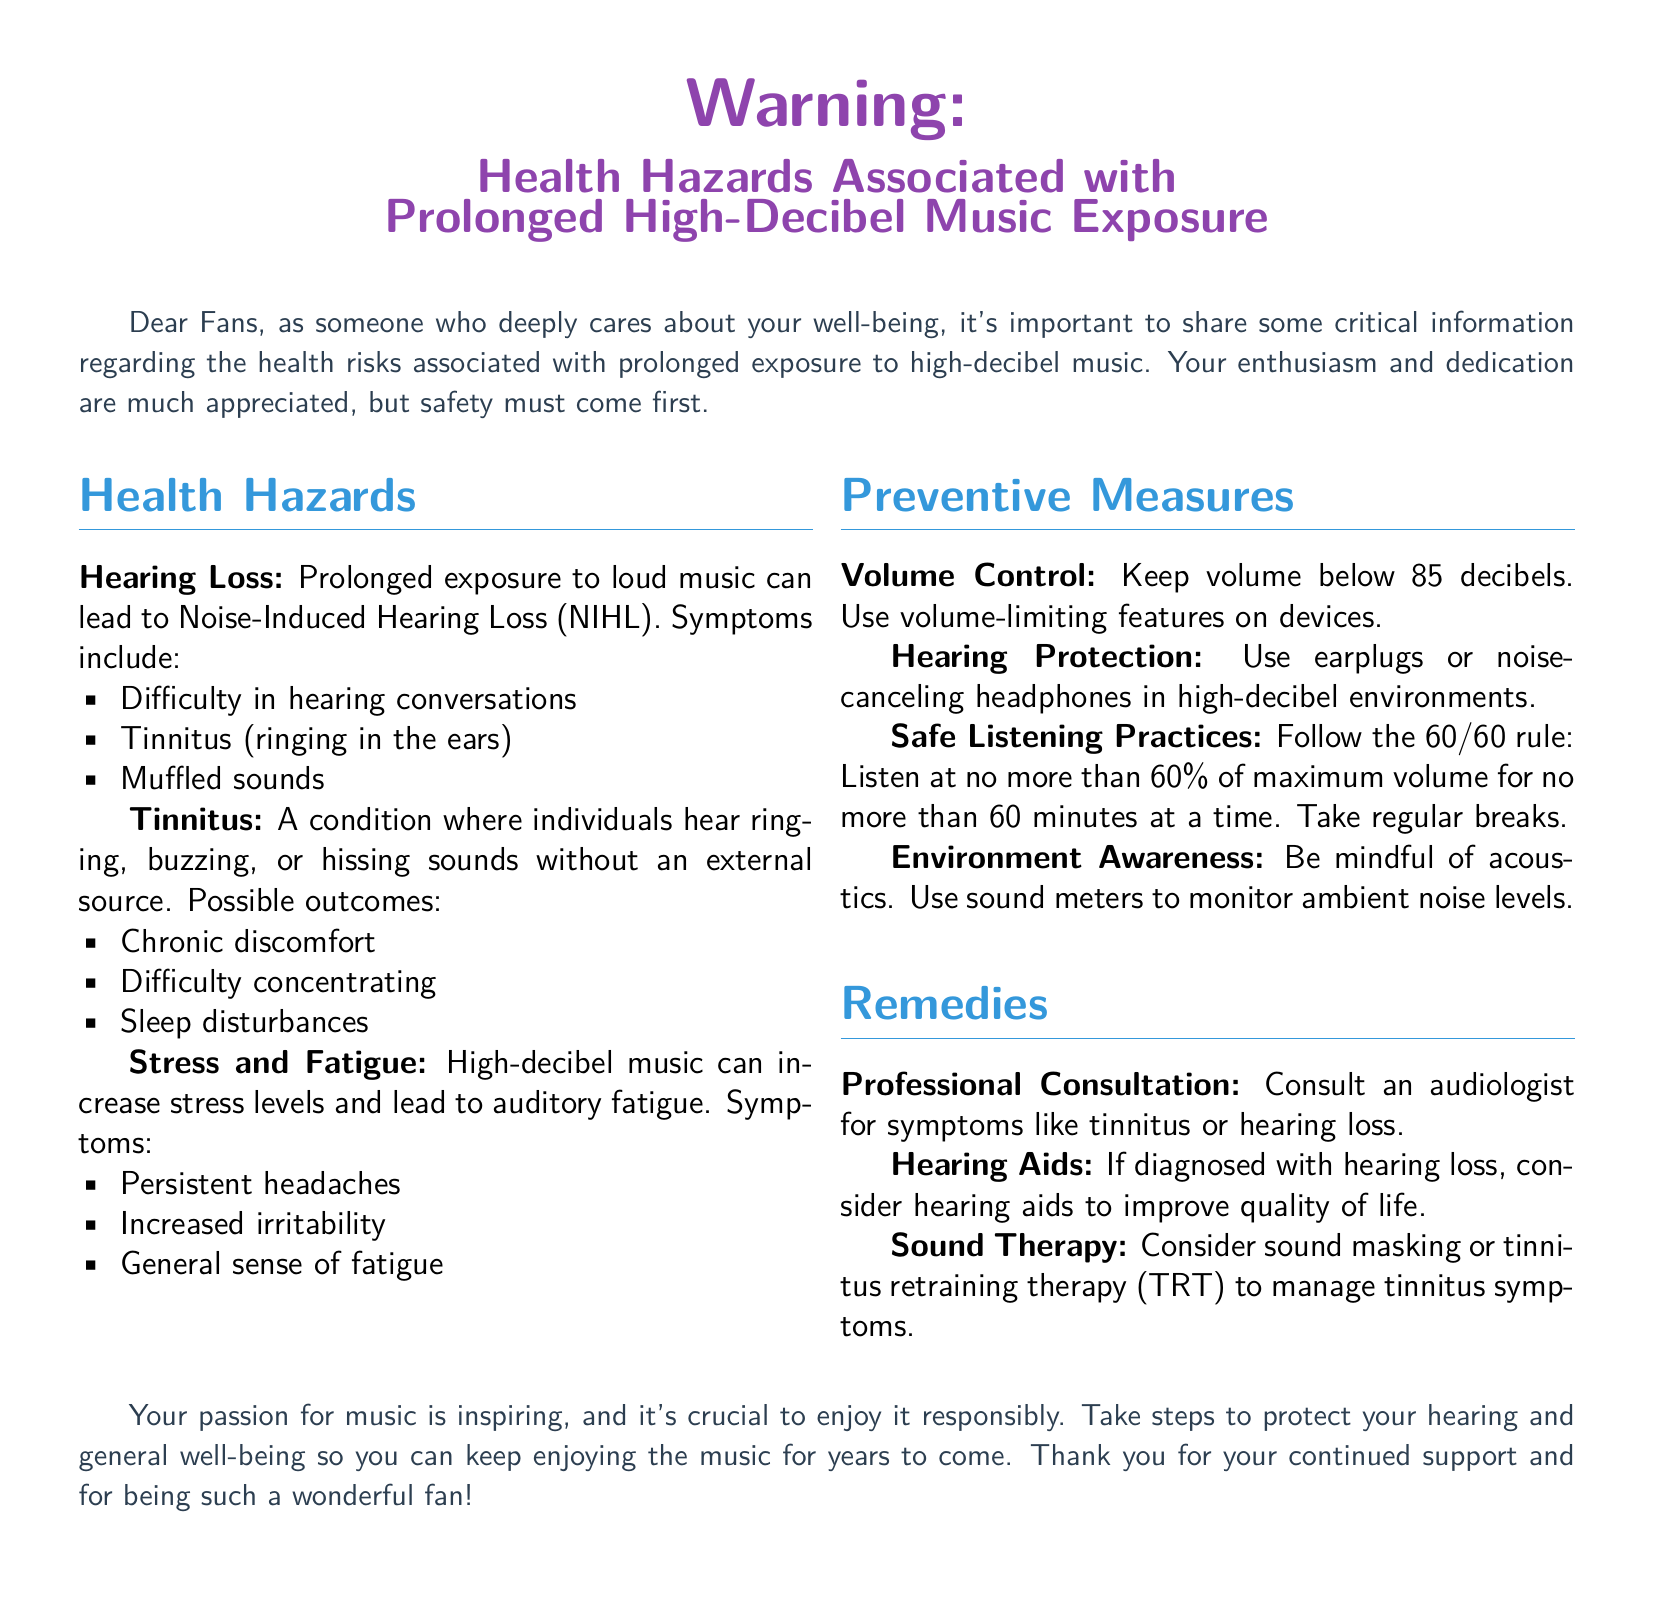What is the main topic of this document? The main topic of the document is about health hazards related to music exposure, specifically high-decibel music.
Answer: Health Hazards Associated with Prolonged High-Decibel Music Exposure What is Noise-Induced Hearing Loss abbreviated as? The document abbreviates Noise-Induced Hearing Loss for convenience, making it easier to reference.
Answer: NIHL What rule is suggested for safe listening practices? The document introduces the 60/60 rule to encourage safer music listening habits in terms of volume and duration.
Answer: 60/60 rule What should be the maximum volume level to avoid hearing hazards? The document specifies a volume limit that can help prevent hearing loss when listening to music.
Answer: 85 decibels Which symptom is associated with Tinnitus? The document lists various symptoms of tinnitus, indicating its impact on auditory perception.
Answer: Ringing in the ears What type of professional should you consult if experiencing hearing loss? The document recommends seeking assistance from a specific type of specialist when symptoms arise.
Answer: Audiologist What remedy involves using devices to improve hearing quality? The document mentions a specific tool that can enhance hearing when diagnosed with hearing problems.
Answer: Hearing aids Which symptom of high-decibel music exposure includes persistent headaches? The document categorizes symptoms of stress and fatigue due to prolonged loud music exposure.
Answer: Stress and Fatigue What is advised to use in high-decibel environments? The document suggests a specific protective item that can help reduce the risks of loud music.
Answer: Earplugs or noise-canceling headphones What is the suggested method for managing tinnitus symptoms? The document provides therapeutic options for individuals dealing with tinnitus, indicating potential relief methods.
Answer: Sound therapy 